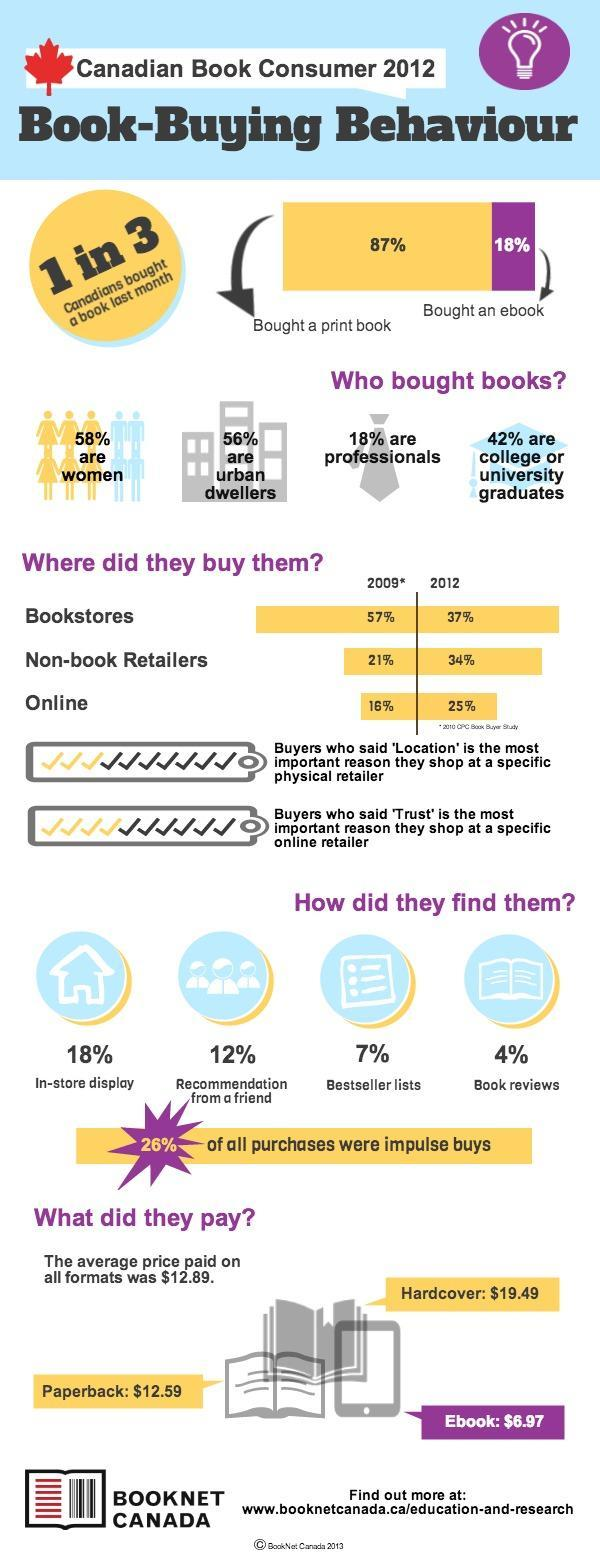How many people found books from bestseller lists and book reviews?
Answer the question with a short phrase. 11% What percent of book buyers are not college or university graduates? 58% In which year did people buying books online increase- 2009 or 2012? 2012 Which is most preferred- print book or ebook? print book Which book format costs the least? Ebook What percent of book buyers are men? 42% What are the various book formats available? Paperback, Hardcover, Ebook Who are the majority of book buyers according to where they live? urban dwellers By what percentage did people buying books from bookstores reduce from 2009 to 2012? 20% 